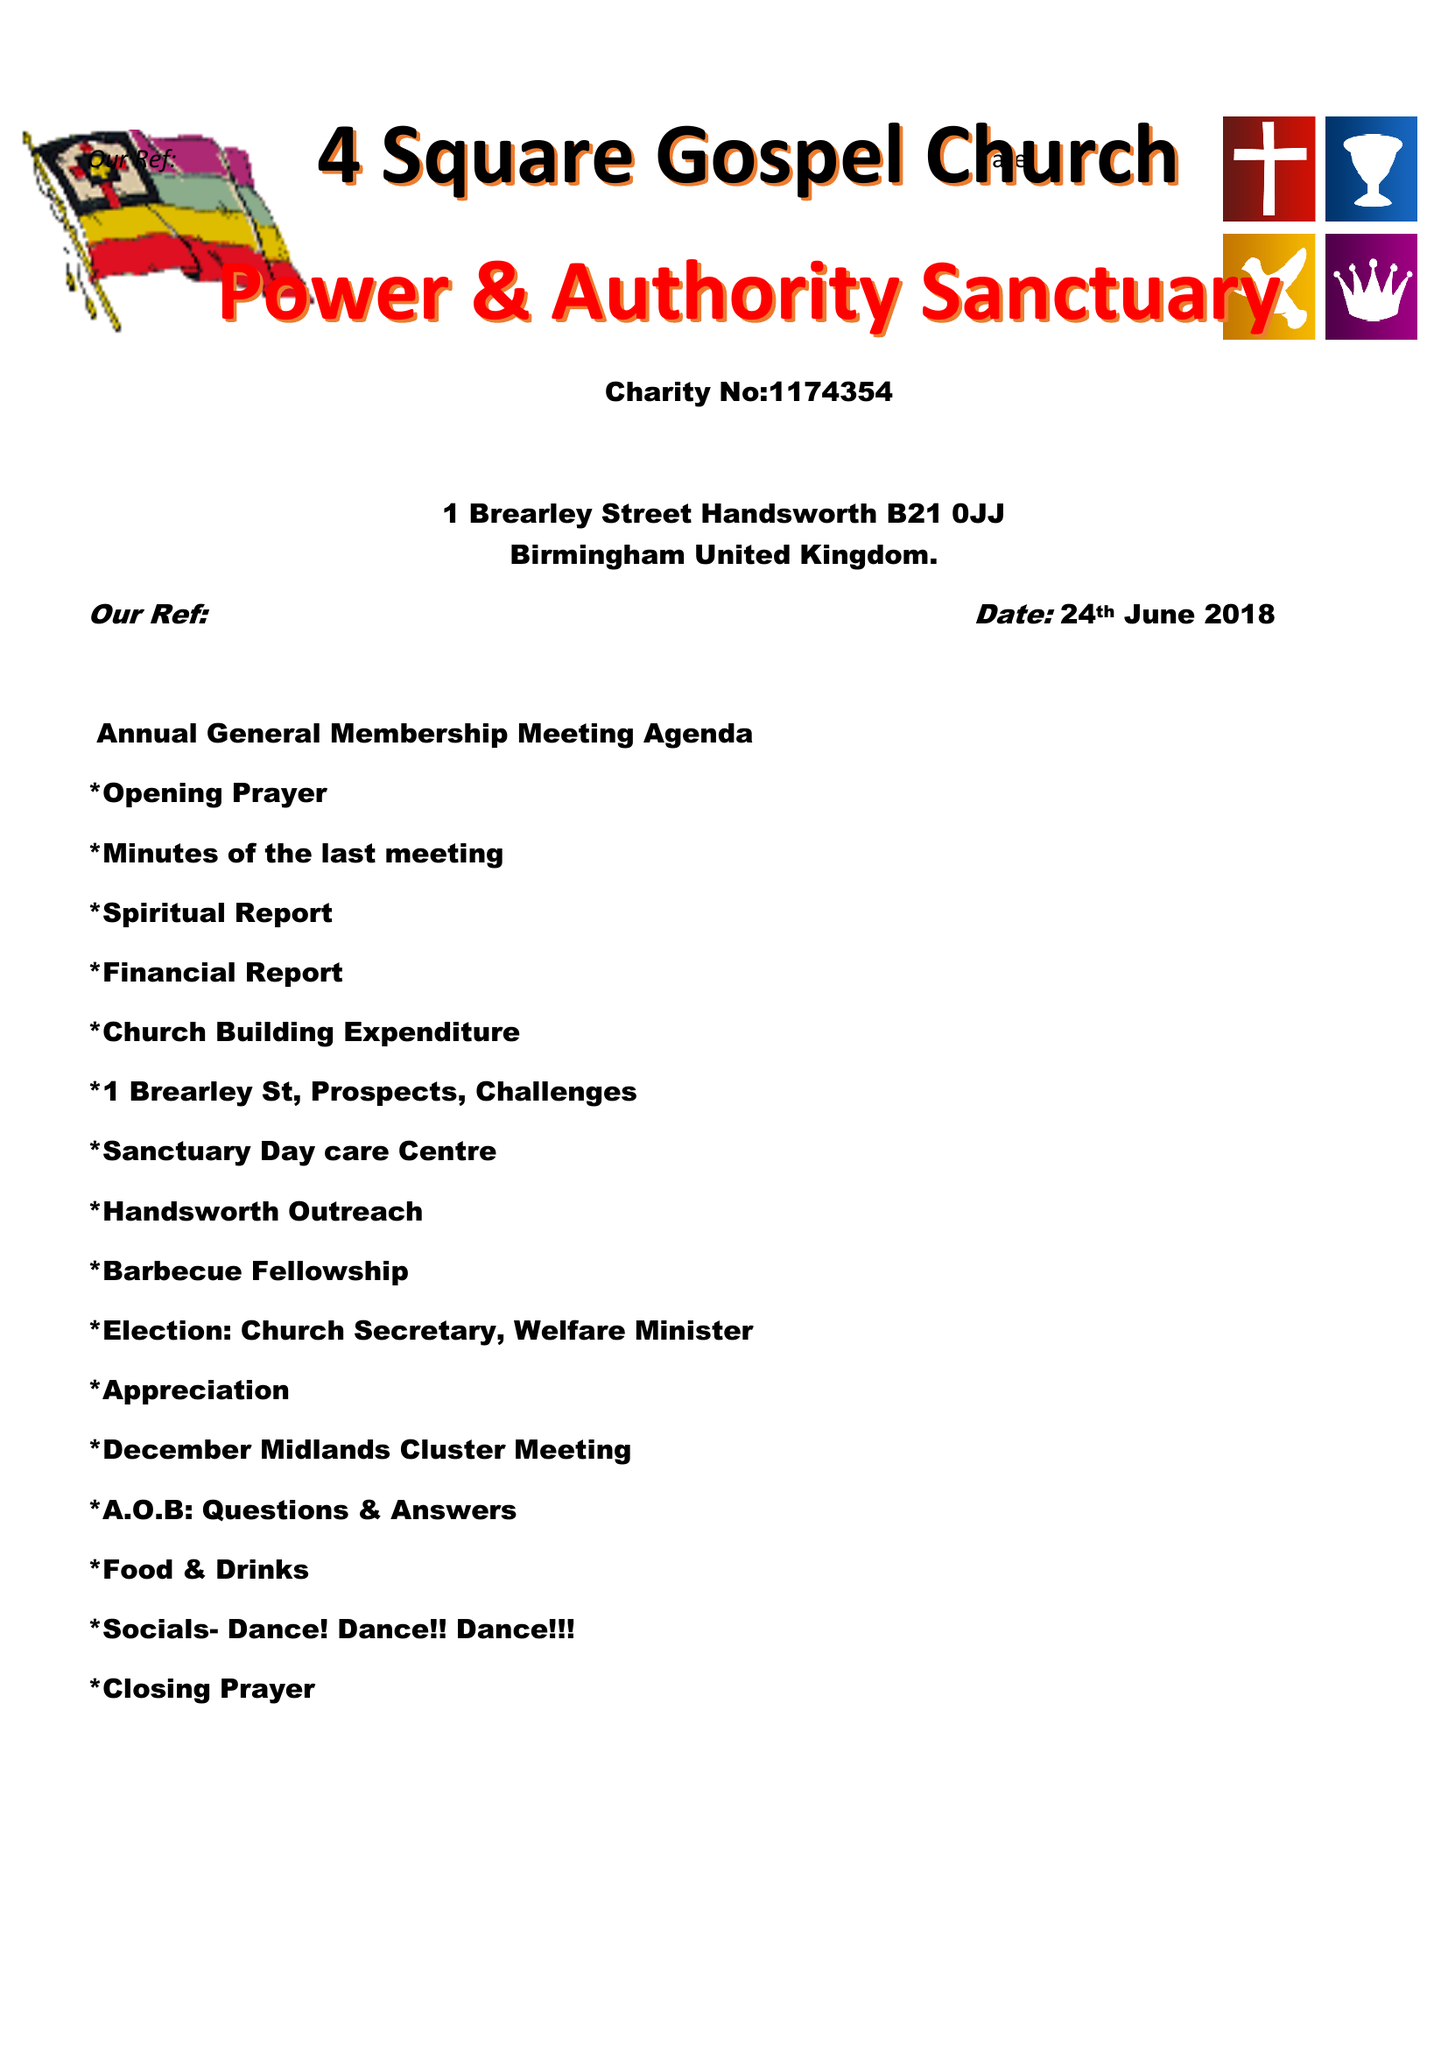What is the value for the report_date?
Answer the question using a single word or phrase. 2018-06-24 